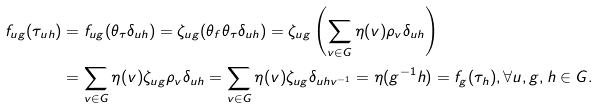<formula> <loc_0><loc_0><loc_500><loc_500>f _ { u g } ( \tau _ { u h } ) & = f _ { u g } ( \theta _ { \tau } \delta _ { u h } ) = \zeta _ { u g } ( \theta _ { f } \theta _ { \tau } \delta _ { u h } ) = \zeta _ { u g } \left ( \sum _ { v \in G } \eta ( v ) \rho _ { v } \delta _ { u h } \right ) \\ & = \sum _ { v \in G } \eta ( v ) \zeta _ { u g } \rho _ { v } \delta _ { u h } = \sum _ { v \in G } \eta ( v ) \zeta _ { u g } \delta _ { u h v ^ { - 1 } } = \eta ( g ^ { - 1 } h ) = f _ { g } ( \tau _ { h } ) , \forall u , g , h \in G .</formula> 